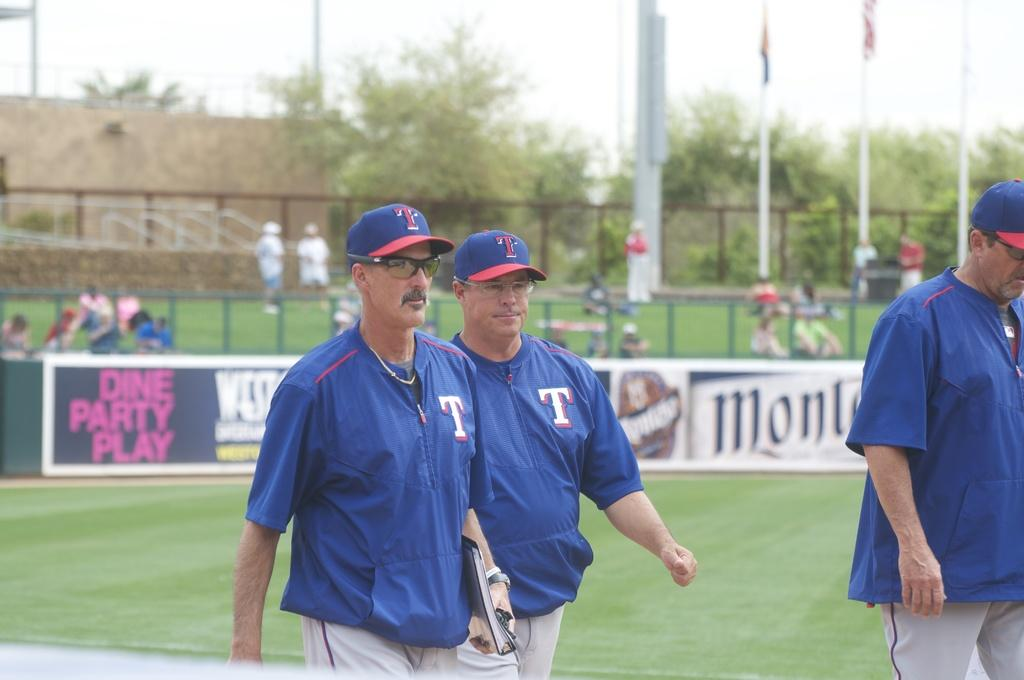<image>
Present a compact description of the photo's key features. Baseball players walk in front of a sign that is about party, play and diner. 